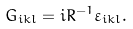Convert formula to latex. <formula><loc_0><loc_0><loc_500><loc_500>G _ { i k l } = i R ^ { - 1 } \varepsilon _ { i k l } .</formula> 